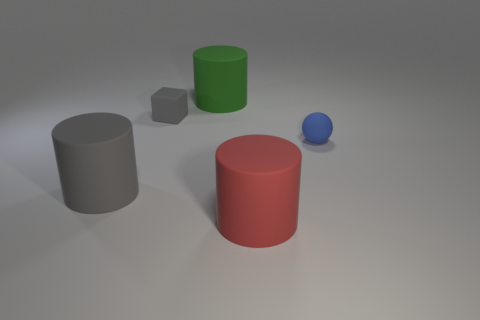There is a rubber thing to the right of the big rubber thing on the right side of the big green cylinder; what shape is it?
Offer a terse response. Sphere. There is a gray rubber object in front of the blue sphere; is its shape the same as the large green object?
Ensure brevity in your answer.  Yes. What is the color of the tiny thing that is to the left of the blue ball?
Make the answer very short. Gray. How many cylinders are either tiny blue things or big rubber things?
Offer a terse response. 3. There is a matte cylinder that is on the left side of the big object behind the tiny blue sphere; what size is it?
Keep it short and to the point. Large. There is a small block; is it the same color as the big matte object that is behind the blue rubber ball?
Your answer should be very brief. No. There is a tiny blue object; what number of large red matte objects are in front of it?
Your response must be concise. 1. Are there fewer matte cylinders than blue things?
Make the answer very short. No. There is a object that is both left of the green thing and on the right side of the large gray matte thing; how big is it?
Your answer should be very brief. Small. There is a thing that is left of the gray block; does it have the same color as the cube?
Your answer should be very brief. Yes. 